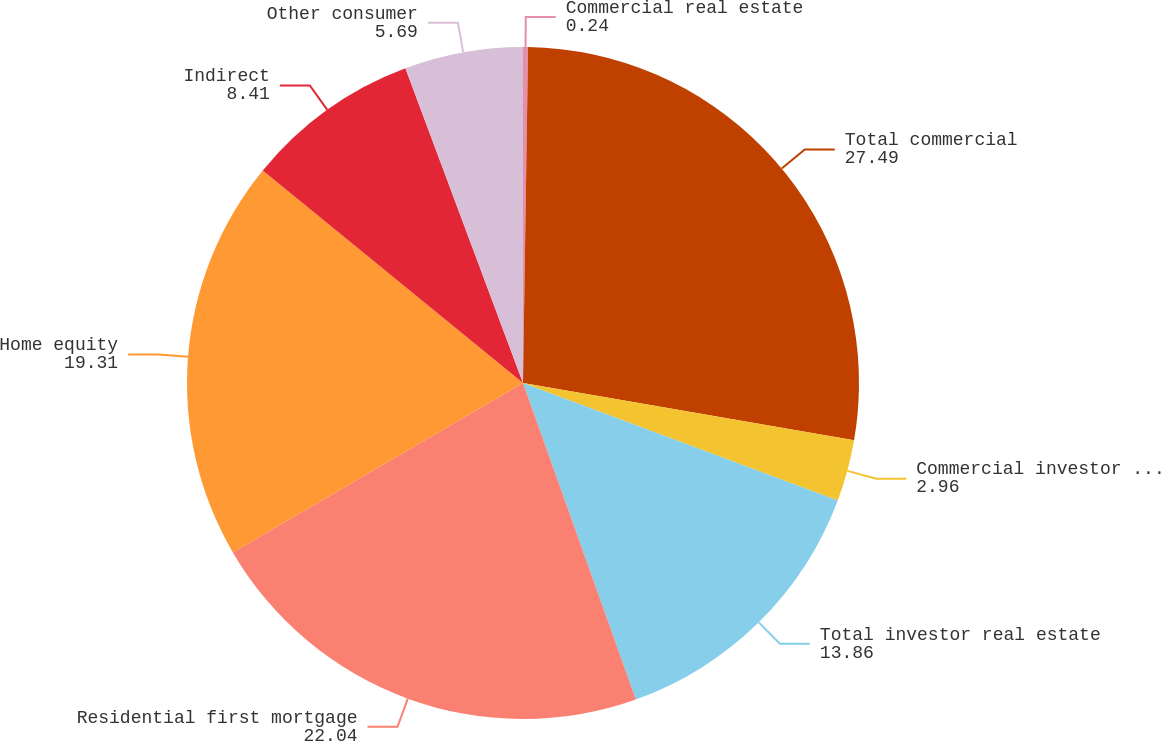<chart> <loc_0><loc_0><loc_500><loc_500><pie_chart><fcel>Commercial real estate<fcel>Total commercial<fcel>Commercial investor real<fcel>Total investor real estate<fcel>Residential first mortgage<fcel>Home equity<fcel>Indirect<fcel>Other consumer<nl><fcel>0.24%<fcel>27.49%<fcel>2.96%<fcel>13.86%<fcel>22.04%<fcel>19.31%<fcel>8.41%<fcel>5.69%<nl></chart> 